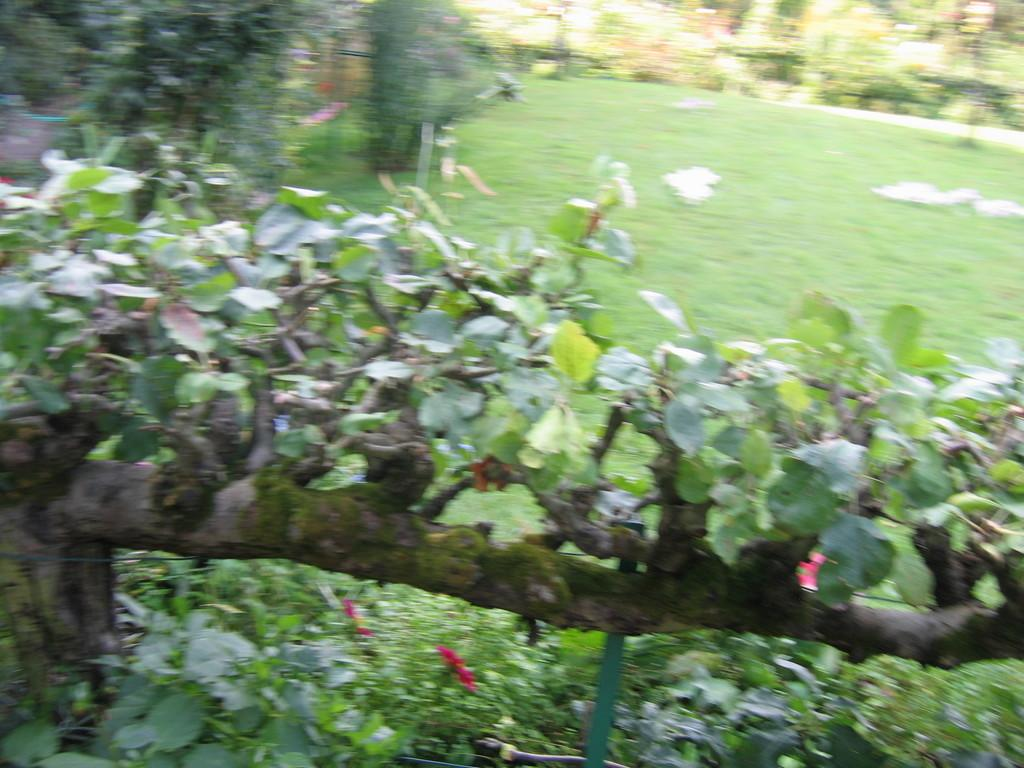What type of vegetation is present at the bottom of the image? There is green grass at the bottom of the image. What can be seen in the foreground of the image? There are green leaves in the foreground of the image. Where are the trees located in the image? There are trees in the left corner and in the background of the image. How many eyes can be seen on the leaves in the image? There are no eyes present on the leaves in the image; they are simply green leaves. 